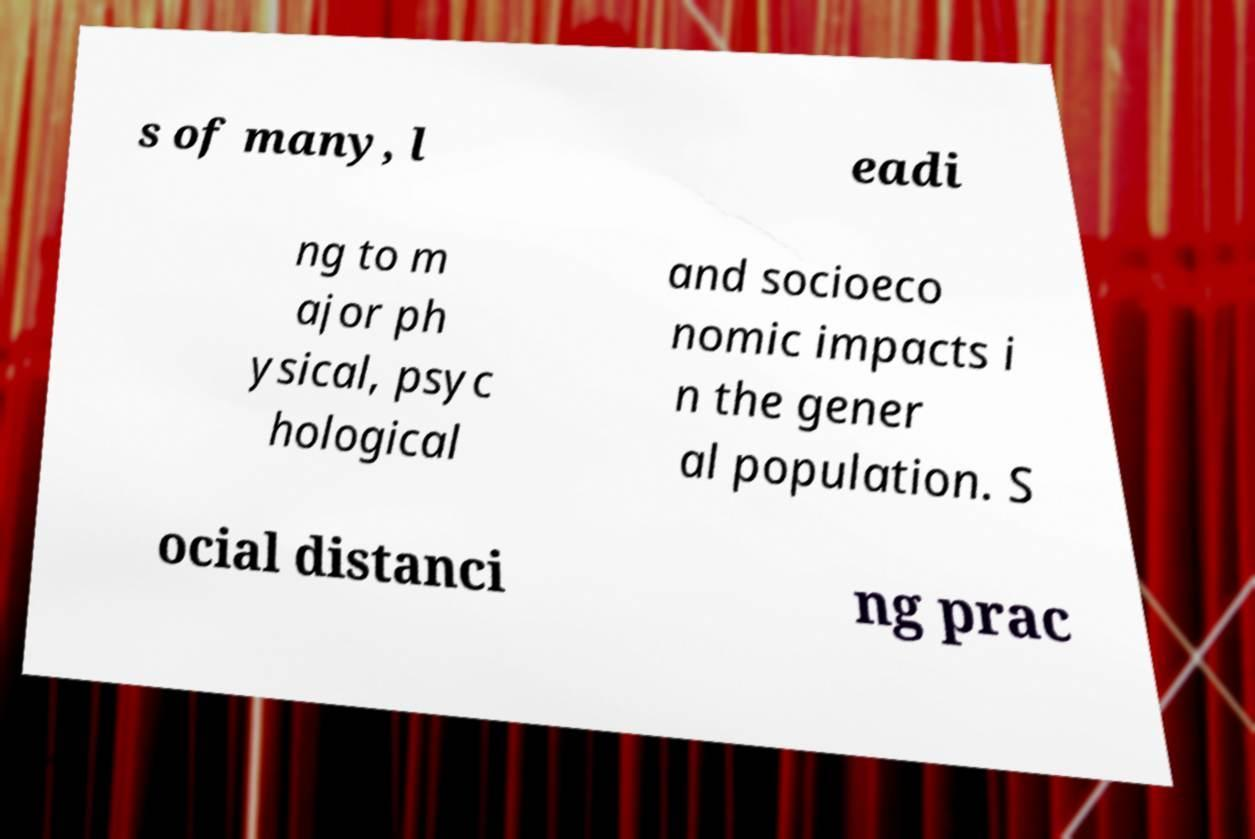For documentation purposes, I need the text within this image transcribed. Could you provide that? s of many, l eadi ng to m ajor ph ysical, psyc hological and socioeco nomic impacts i n the gener al population. S ocial distanci ng prac 